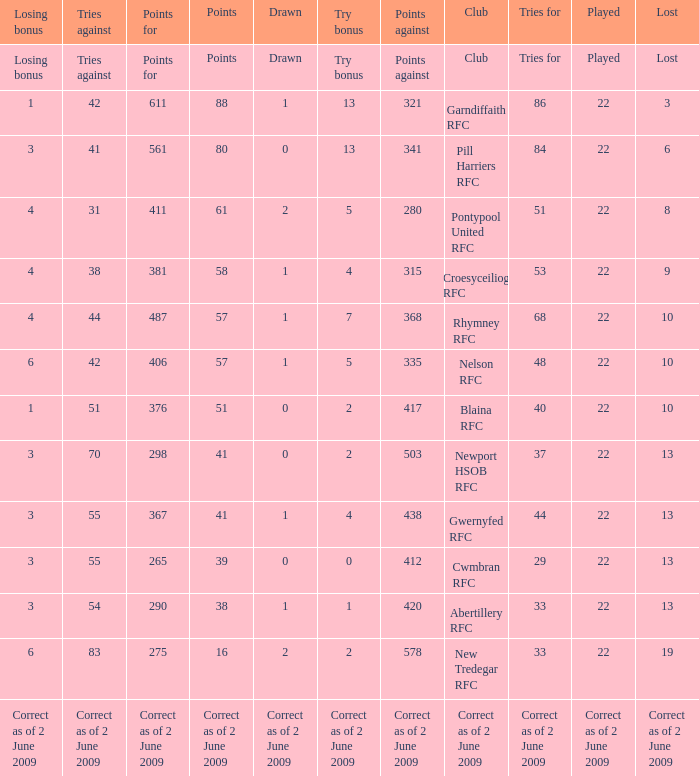Which club has 40 tries for? Blaina RFC. Would you mind parsing the complete table? {'header': ['Losing bonus', 'Tries against', 'Points for', 'Points', 'Drawn', 'Try bonus', 'Points against', 'Club', 'Tries for', 'Played', 'Lost'], 'rows': [['Losing bonus', 'Tries against', 'Points for', 'Points', 'Drawn', 'Try bonus', 'Points against', 'Club', 'Tries for', 'Played', 'Lost'], ['1', '42', '611', '88', '1', '13', '321', 'Garndiffaith RFC', '86', '22', '3'], ['3', '41', '561', '80', '0', '13', '341', 'Pill Harriers RFC', '84', '22', '6'], ['4', '31', '411', '61', '2', '5', '280', 'Pontypool United RFC', '51', '22', '8'], ['4', '38', '381', '58', '1', '4', '315', 'Croesyceiliog RFC', '53', '22', '9'], ['4', '44', '487', '57', '1', '7', '368', 'Rhymney RFC', '68', '22', '10'], ['6', '42', '406', '57', '1', '5', '335', 'Nelson RFC', '48', '22', '10'], ['1', '51', '376', '51', '0', '2', '417', 'Blaina RFC', '40', '22', '10'], ['3', '70', '298', '41', '0', '2', '503', 'Newport HSOB RFC', '37', '22', '13'], ['3', '55', '367', '41', '1', '4', '438', 'Gwernyfed RFC', '44', '22', '13'], ['3', '55', '265', '39', '0', '0', '412', 'Cwmbran RFC', '29', '22', '13'], ['3', '54', '290', '38', '1', '1', '420', 'Abertillery RFC', '33', '22', '13'], ['6', '83', '275', '16', '2', '2', '578', 'New Tredegar RFC', '33', '22', '19'], ['Correct as of 2 June 2009', 'Correct as of 2 June 2009', 'Correct as of 2 June 2009', 'Correct as of 2 June 2009', 'Correct as of 2 June 2009', 'Correct as of 2 June 2009', 'Correct as of 2 June 2009', 'Correct as of 2 June 2009', 'Correct as of 2 June 2009', 'Correct as of 2 June 2009', 'Correct as of 2 June 2009']]} 